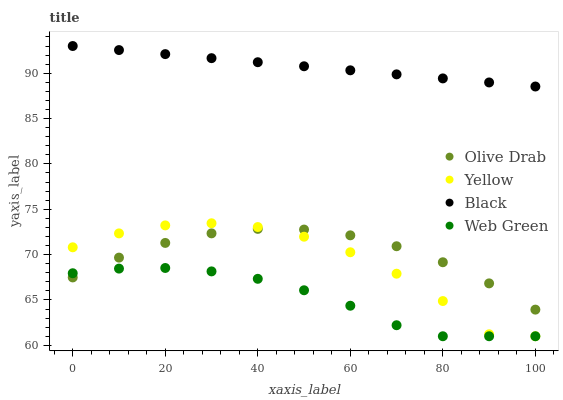Does Web Green have the minimum area under the curve?
Answer yes or no. Yes. Does Black have the maximum area under the curve?
Answer yes or no. Yes. Does Yellow have the minimum area under the curve?
Answer yes or no. No. Does Yellow have the maximum area under the curve?
Answer yes or no. No. Is Black the smoothest?
Answer yes or no. Yes. Is Yellow the roughest?
Answer yes or no. Yes. Is Yellow the smoothest?
Answer yes or no. No. Is Black the roughest?
Answer yes or no. No. Does Web Green have the lowest value?
Answer yes or no. Yes. Does Black have the lowest value?
Answer yes or no. No. Does Black have the highest value?
Answer yes or no. Yes. Does Yellow have the highest value?
Answer yes or no. No. Is Olive Drab less than Black?
Answer yes or no. Yes. Is Black greater than Olive Drab?
Answer yes or no. Yes. Does Yellow intersect Olive Drab?
Answer yes or no. Yes. Is Yellow less than Olive Drab?
Answer yes or no. No. Is Yellow greater than Olive Drab?
Answer yes or no. No. Does Olive Drab intersect Black?
Answer yes or no. No. 